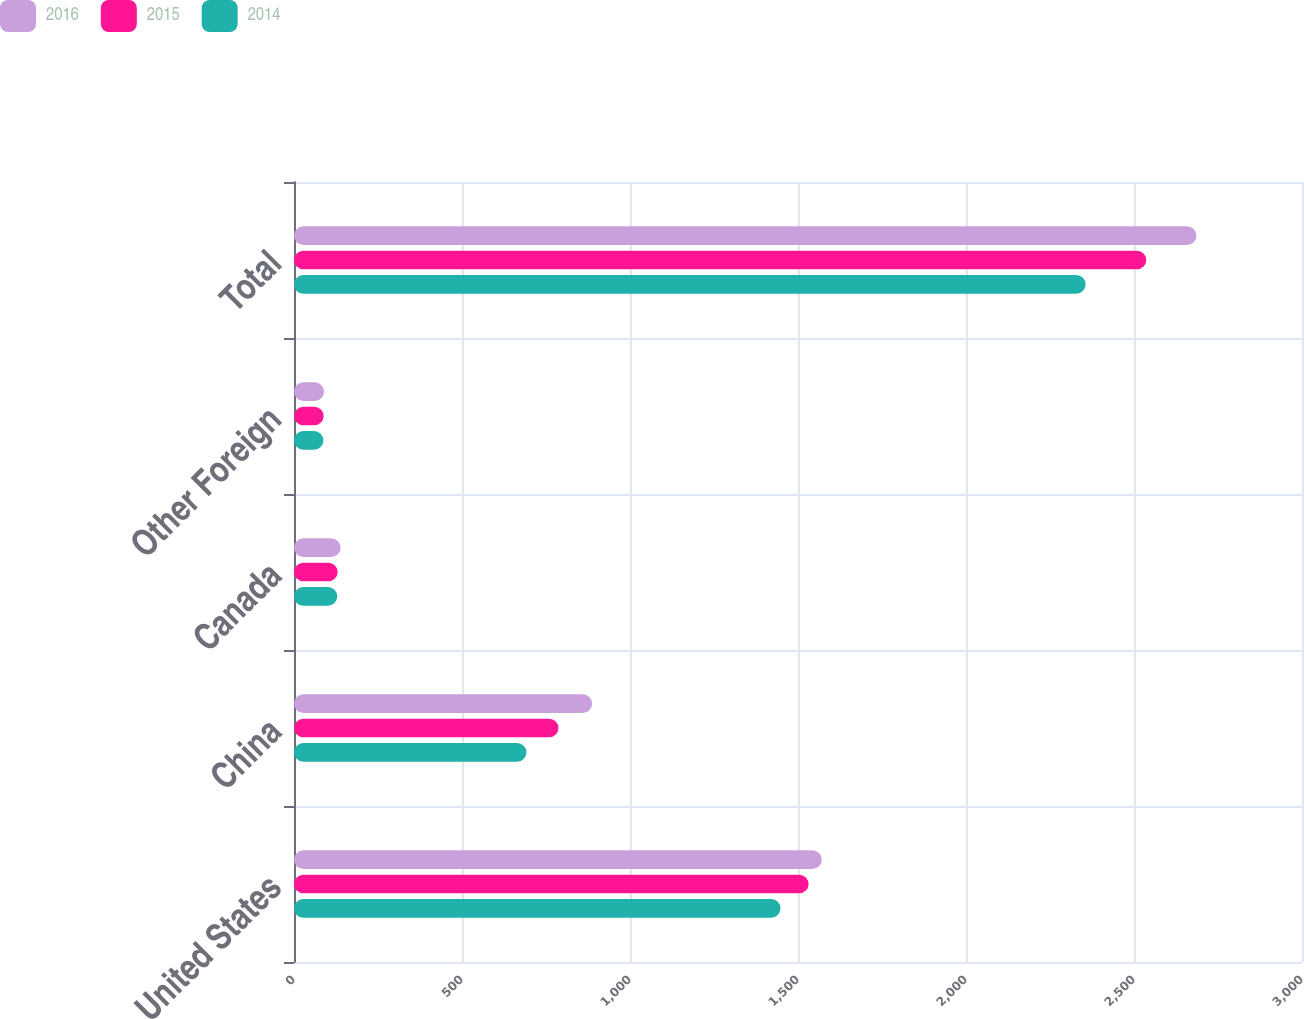<chart> <loc_0><loc_0><loc_500><loc_500><stacked_bar_chart><ecel><fcel>United States<fcel>China<fcel>Canada<fcel>Other Foreign<fcel>Total<nl><fcel>2016<fcel>1570.7<fcel>887.1<fcel>138.7<fcel>89.4<fcel>2685.9<nl><fcel>2015<fcel>1531.4<fcel>787.1<fcel>129.9<fcel>88.1<fcel>2536.5<nl><fcel>2014<fcel>1447.9<fcel>691.8<fcel>128.8<fcel>87.5<fcel>2356<nl></chart> 